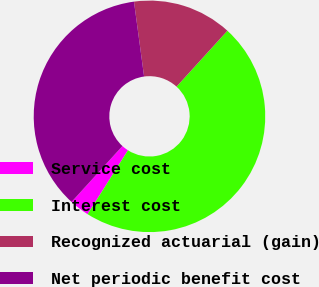Convert chart to OTSL. <chart><loc_0><loc_0><loc_500><loc_500><pie_chart><fcel>Service cost<fcel>Interest cost<fcel>Recognized actuarial (gain)<fcel>Net periodic benefit cost<nl><fcel>2.78%<fcel>47.22%<fcel>13.89%<fcel>36.11%<nl></chart> 